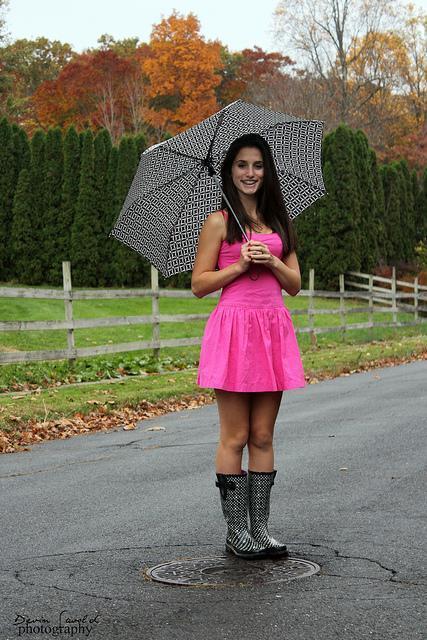How many zebras are there?
Give a very brief answer. 0. 